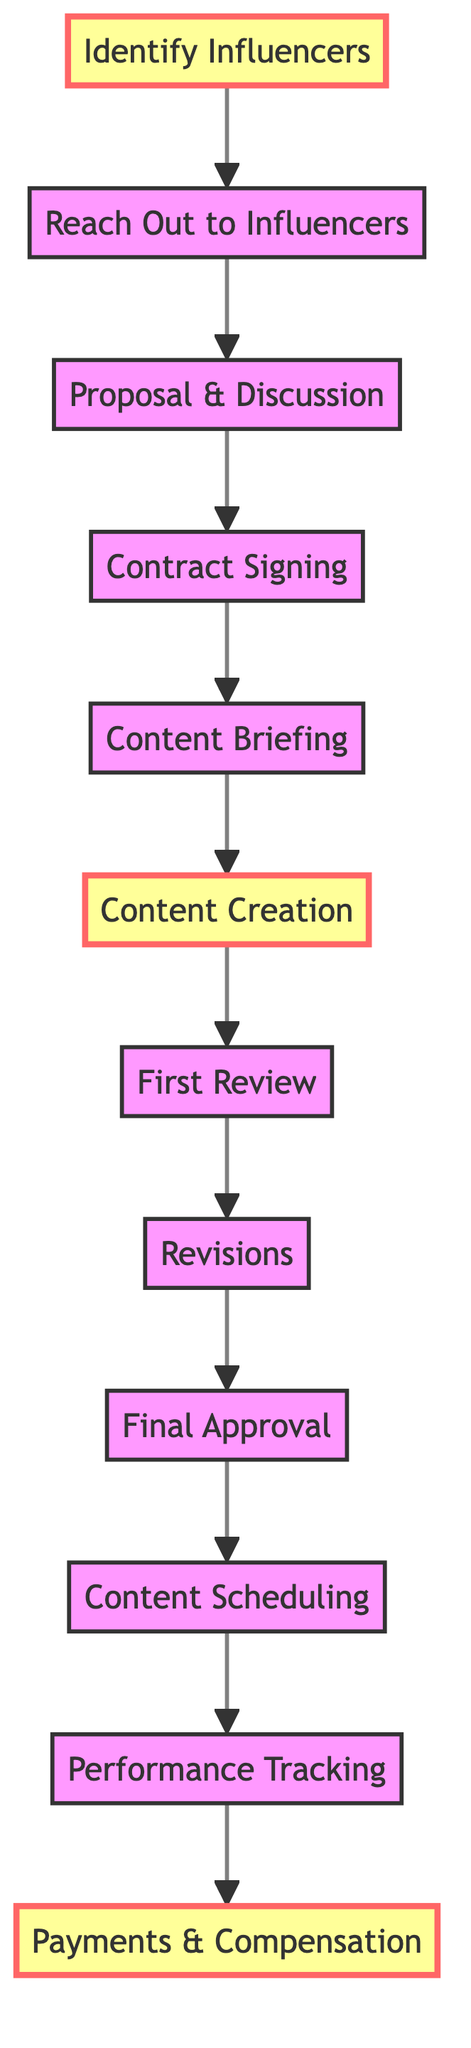What is the first step in the content creation workflow? The diagram shows that the first node in the workflow is "Identify Influencers," which indicates it is the starting point of the process.
Answer: Identify Influencers How many total nodes are in the diagram? By counting the unique activities/nodes listed in the diagram, there are 12 nodes present overall.
Answer: 12 What comes after "Content Creation"? Looking at the directed edges, the next activity following "Content Creation" is "First Review," indicating it is the subsequent step in the workflow.
Answer: First Review Which step directly follows "Final Approval"? The directed graph indicates that "Content Scheduling" is the immediate next step after "Final Approval," showing the sequence of the workflow.
Answer: Content Scheduling How many edges are in the diagram? Counting the connections between the nodes in the directed graph shows there are 11 edges present, representing the flow between different steps.
Answer: 11 What is the last step in the content creation workflow? Tracing the flow from the last node, "Payments & Compensation," confirms that it is the endpoint of the entire workflow process, summarizing the final outcome.
Answer: Payments & Compensation Which two nodes are directly connected to "Revisions"? The edges show that "Revisions" is connected to both "First Review" and "Final Approval," indicating the flow of activities before and after this step.
Answer: First Review, Final Approval Which node has the most connections leading into it? Observing the edges, "Final Approval" has one incoming edge from "Revisions," while other nodes like "Identify Influencers" only have outgoing edges. Thus, no node has more connections leading into it than "Final Approval" except itself.
Answer: Final Approval What are the two highlighted nodes in the diagram? The highlighting in the diagram indicates "Identify Influencers," and "Content Creation" are important stages, making them easily identifiable as key components of the workflow.
Answer: Identify Influencers, Content Creation 